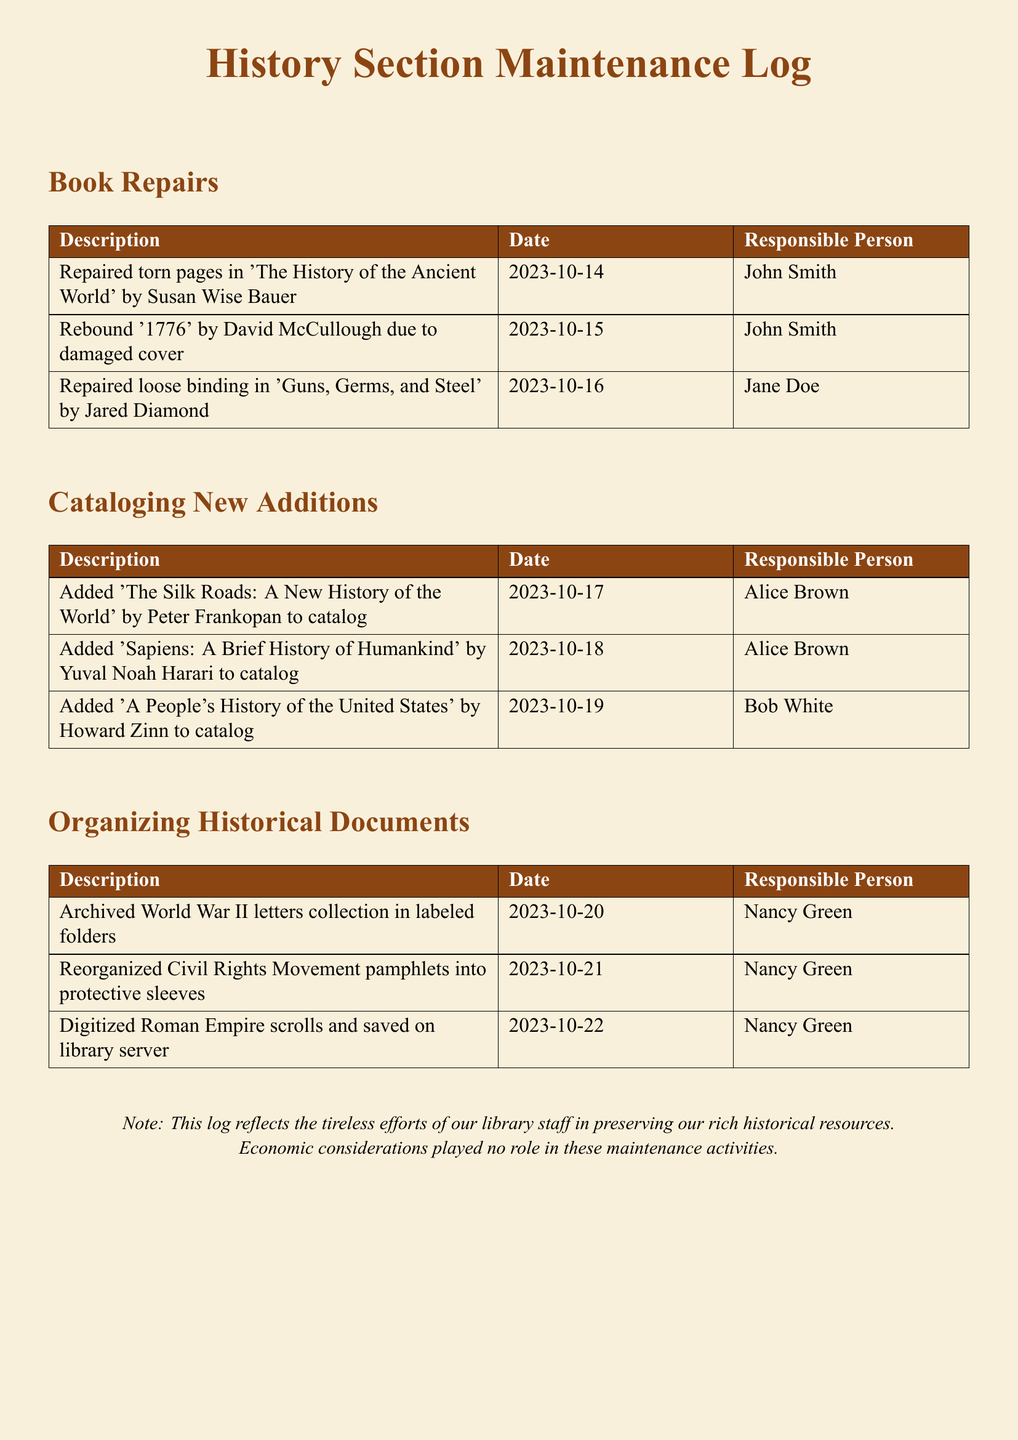What is the title of the book repaired by John Smith on October 14, 2023? The title is mentioned in the book repairs section along with the responsible person and date.
Answer: The History of the Ancient World Who added 'A People's History of the United States' to the catalog? The responsible person is listed in the cataloging new additions section alongside the book title and date.
Answer: Bob White When were the Civil Rights Movement pamphlets reorganized? The date is clearly stated in the organizing historical documents section along with the description and responsible person.
Answer: 2023-10-21 How many books were cataloged by Alice Brown? The number can be determined by counting the entries under cataloging new additions that list Alice Brown as the responsible person.
Answer: 2 What type of documents were digitized by Nancy Green? The type of documents is clearly listed in the organizing historical documents section along with a description and date.
Answer: Roman Empire scrolls What is the color theme used in the document? The color theme can be inferred from the document formatting and specific color mentions throughout the log.
Answer: History brown Who was responsible for repairing the book '1776'? The responsible person is detailed in the book repairs section, specifying who completed that particular task.
Answer: John Smith What date was the collection of World War II letters archived? The date can be found in the organizing historical documents section next to the description.
Answer: 2023-10-20 How many entries are there in the book repairs section? The number of entries can be counted from the table in the book repairs section.
Answer: 3 